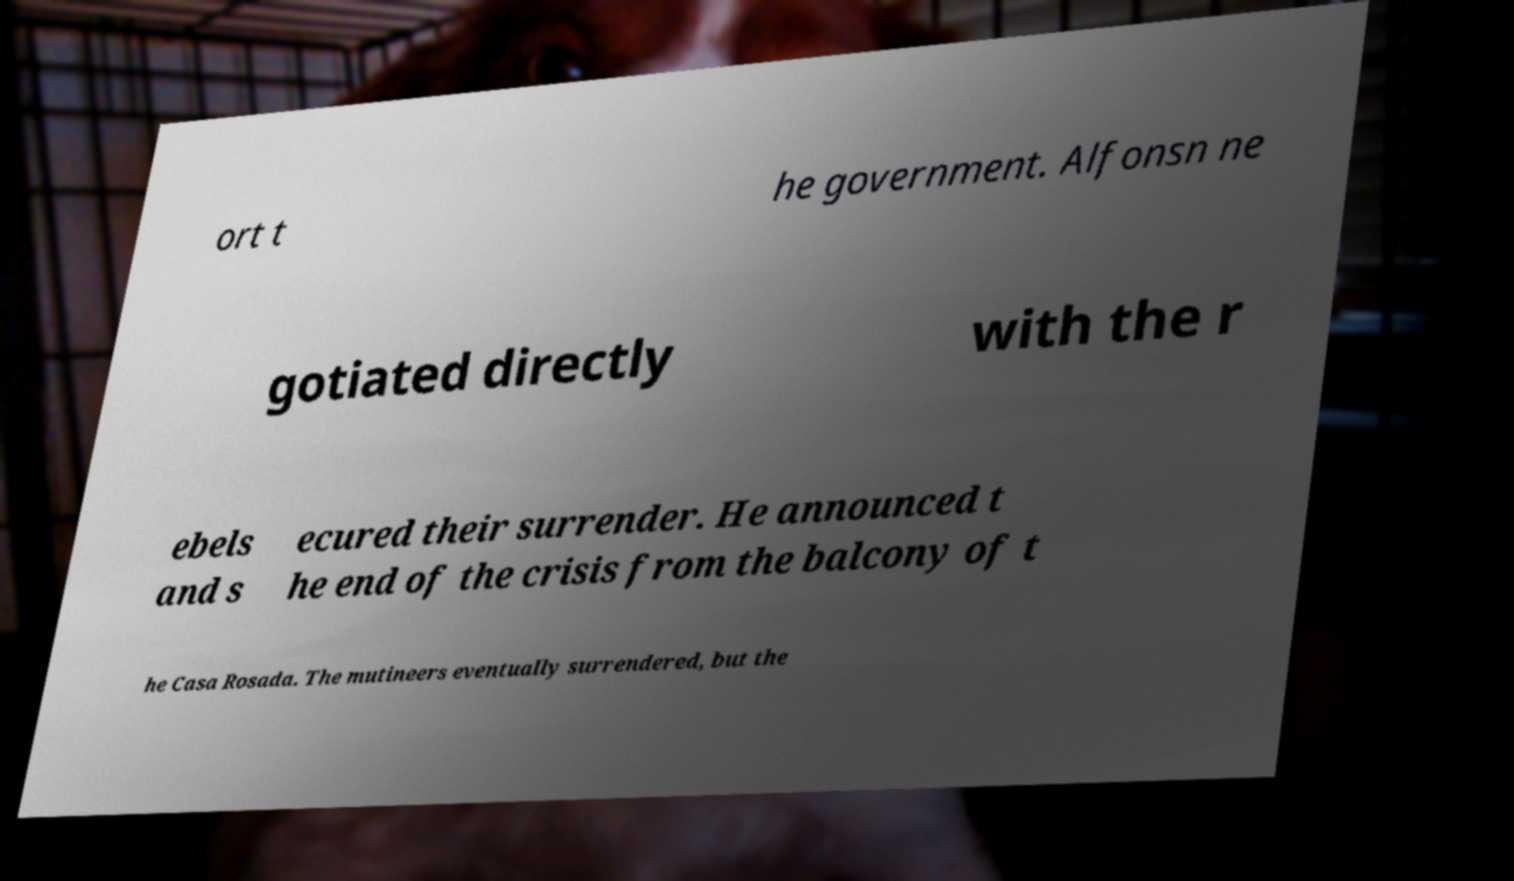Please identify and transcribe the text found in this image. ort t he government. Alfonsn ne gotiated directly with the r ebels and s ecured their surrender. He announced t he end of the crisis from the balcony of t he Casa Rosada. The mutineers eventually surrendered, but the 